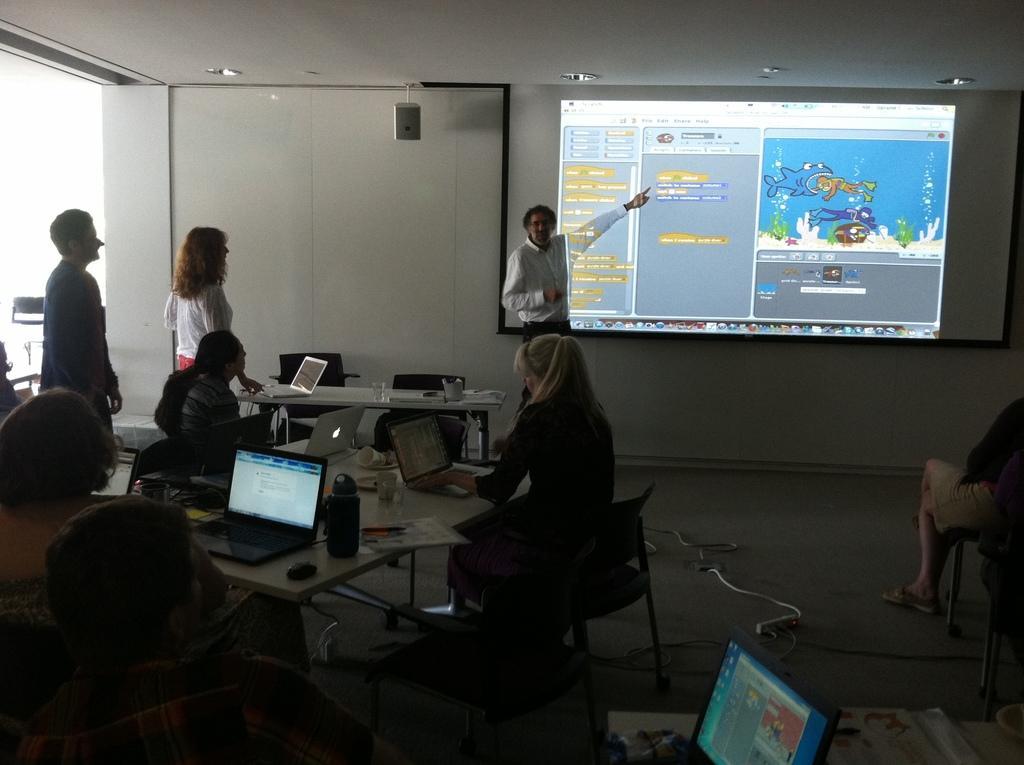Describe this image in one or two sentences. A group of people are listening to man whose is presenting at a screen behind him. 